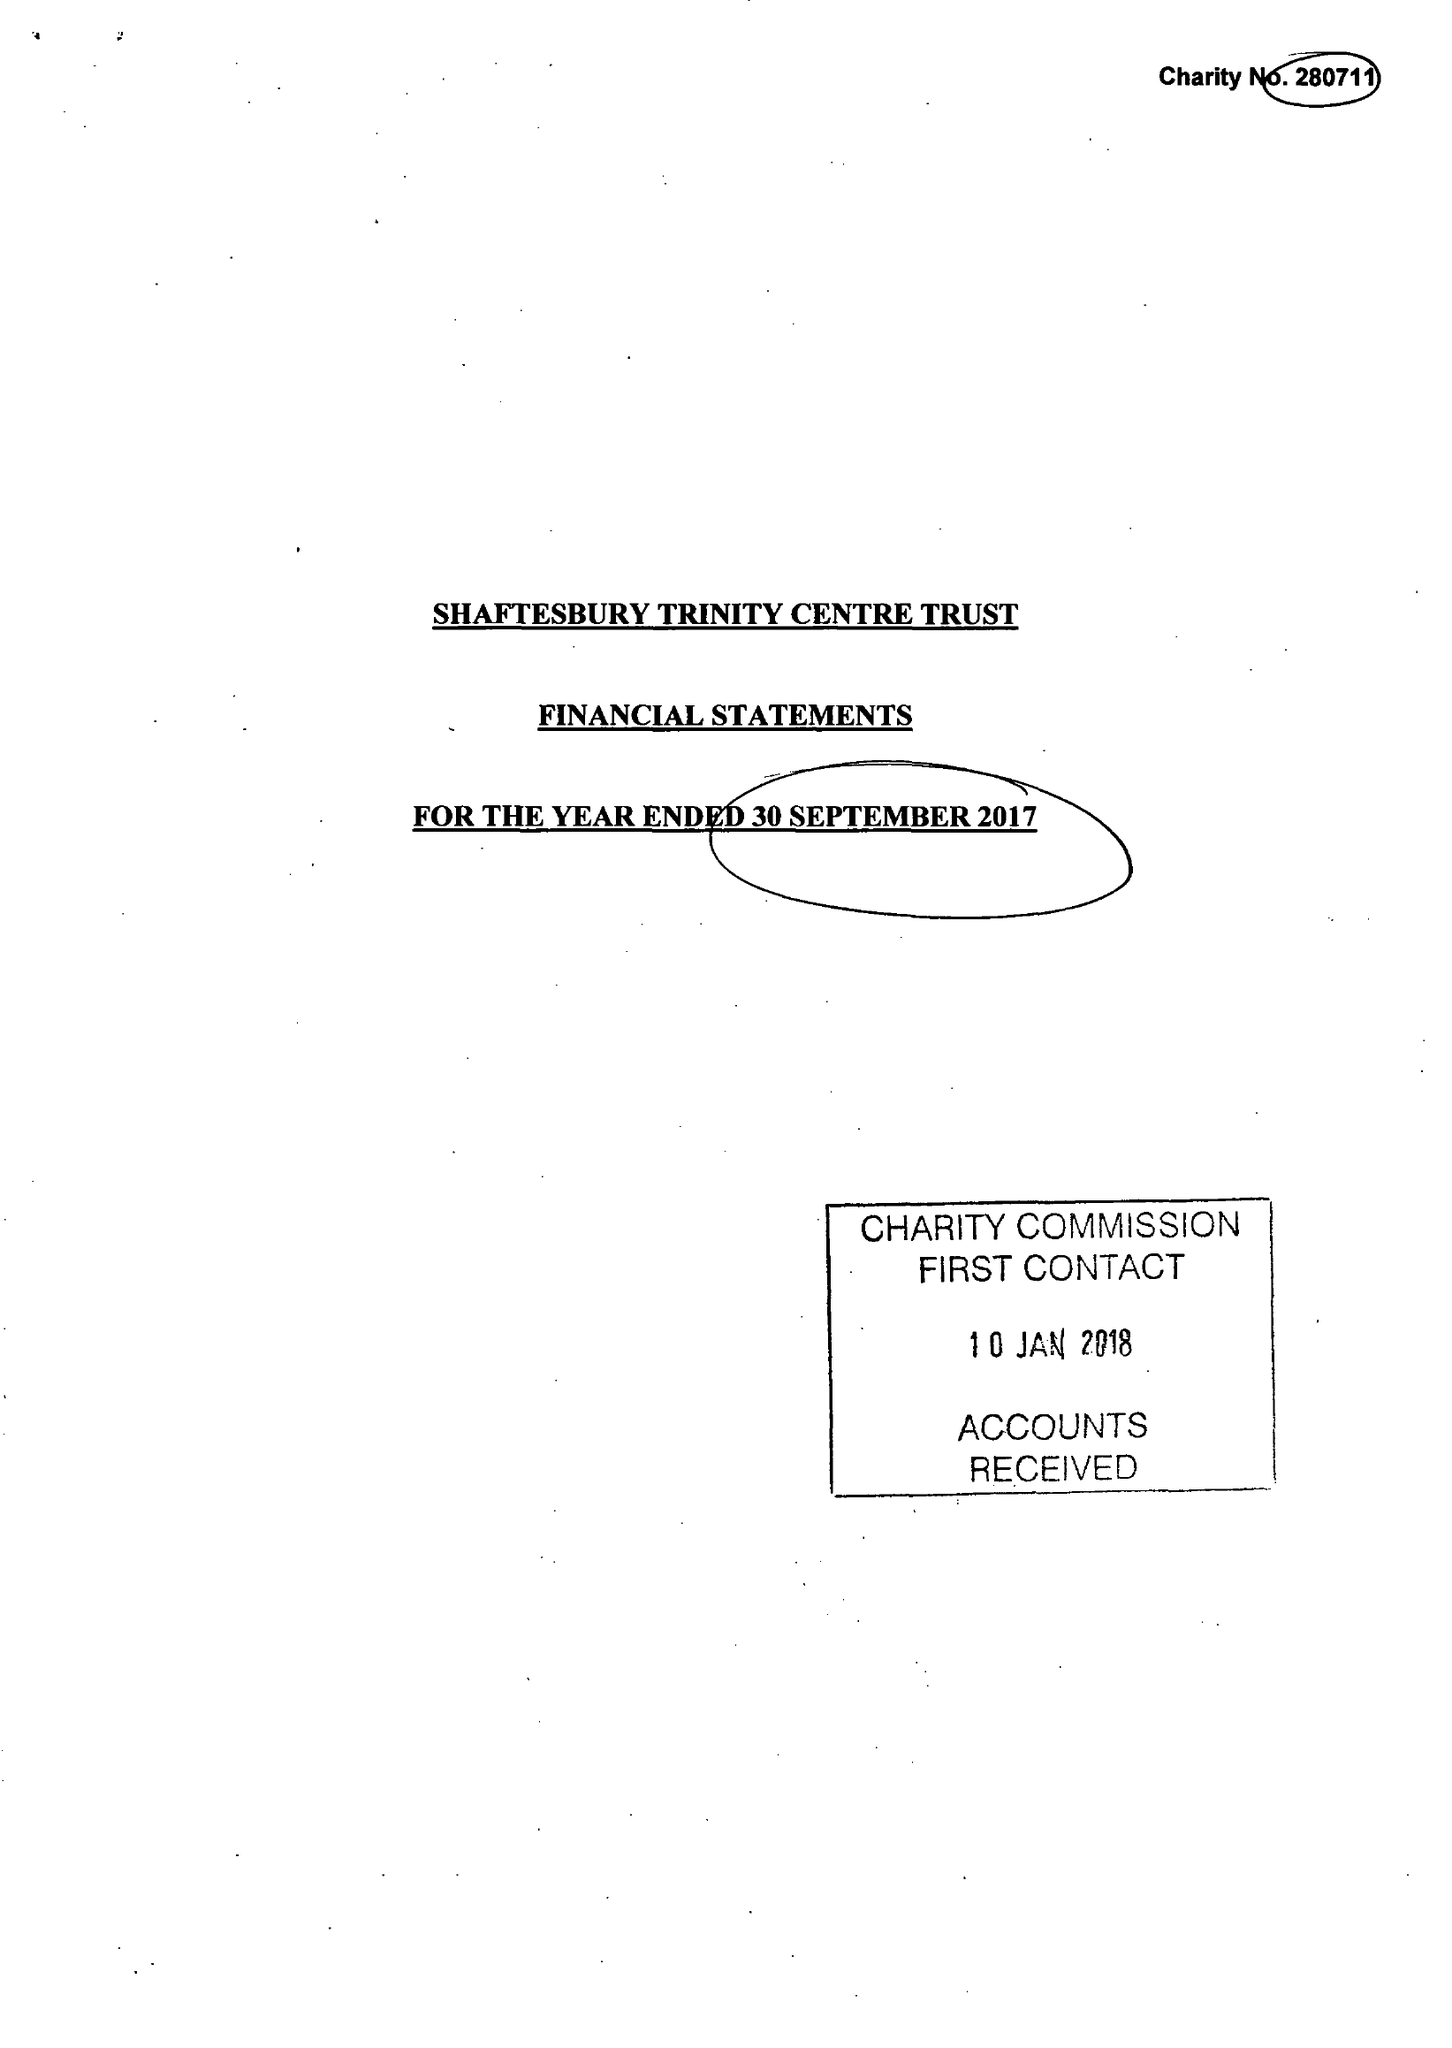What is the value for the charity_number?
Answer the question using a single word or phrase. 280711 